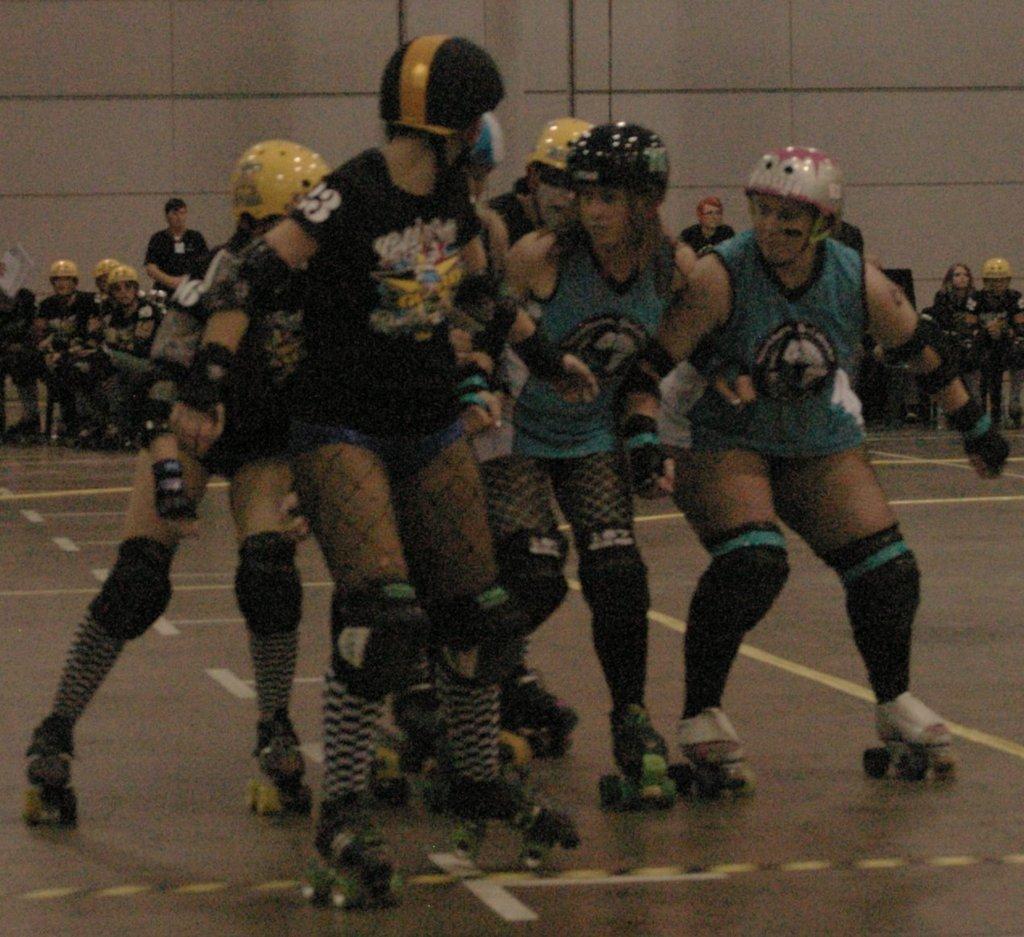Can you describe this image briefly? In the foreground of the picture we can see a group of women, skating. In the middle of the picture there are people, chairs and other objects. In the background it is looking like a wall. 